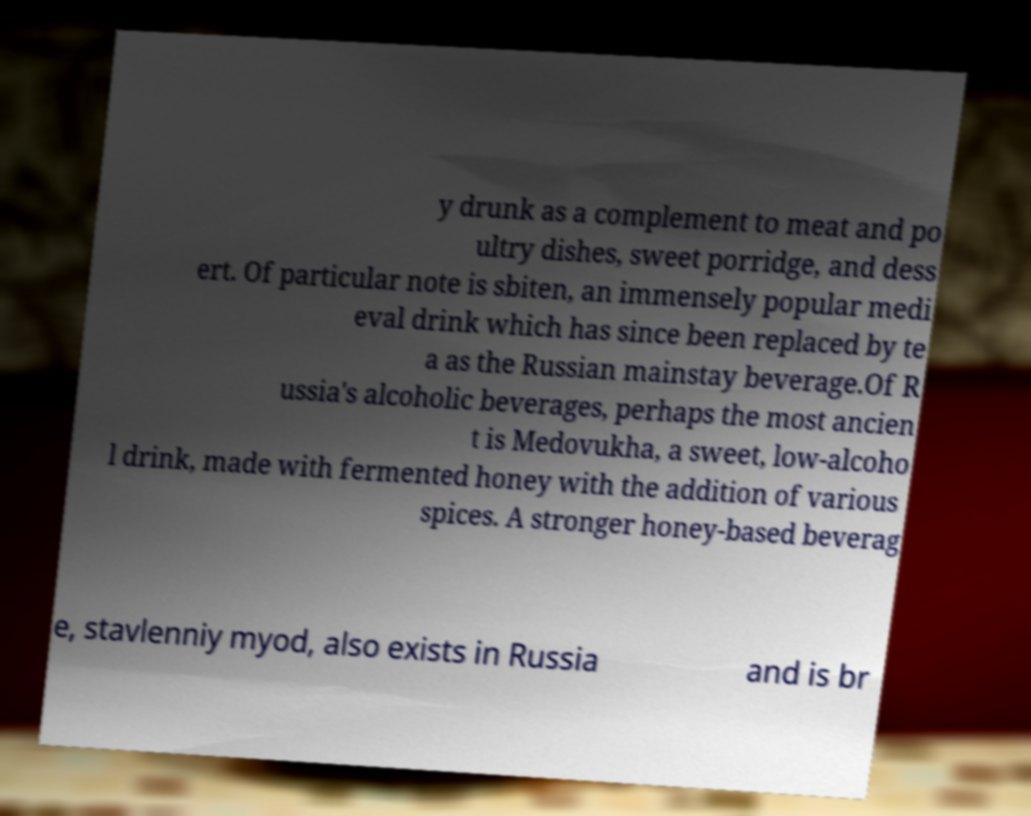For documentation purposes, I need the text within this image transcribed. Could you provide that? y drunk as a complement to meat and po ultry dishes, sweet porridge, and dess ert. Of particular note is sbiten, an immensely popular medi eval drink which has since been replaced by te a as the Russian mainstay beverage.Of R ussia's alcoholic beverages, perhaps the most ancien t is Medovukha, a sweet, low-alcoho l drink, made with fermented honey with the addition of various spices. A stronger honey-based beverag e, stavlenniy myod, also exists in Russia and is br 